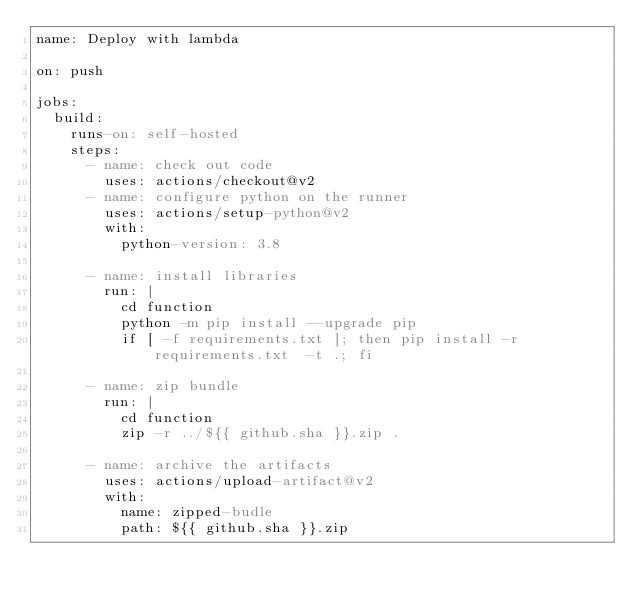<code> <loc_0><loc_0><loc_500><loc_500><_YAML_>name: Deploy with lambda  

on: push

jobs:
  build: 
    runs-on: self-hosted
    steps:
      - name: check out code
        uses: actions/checkout@v2
      - name: configure python on the runner
        uses: actions/setup-python@v2
        with:
          python-version: 3.8

      - name: install libraries
        run: |
          cd function
          python -m pip install --upgrade pip
          if [ -f requirements.txt ]; then pip install -r requirements.txt  -t .; fi

      - name: zip bundle
        run: |
          cd function
          zip -r ../${{ github.sha }}.zip .
    
      - name: archive the artifacts
        uses: actions/upload-artifact@v2
        with:
          name: zipped-budle
          path: ${{ github.sha }}.zip</code> 